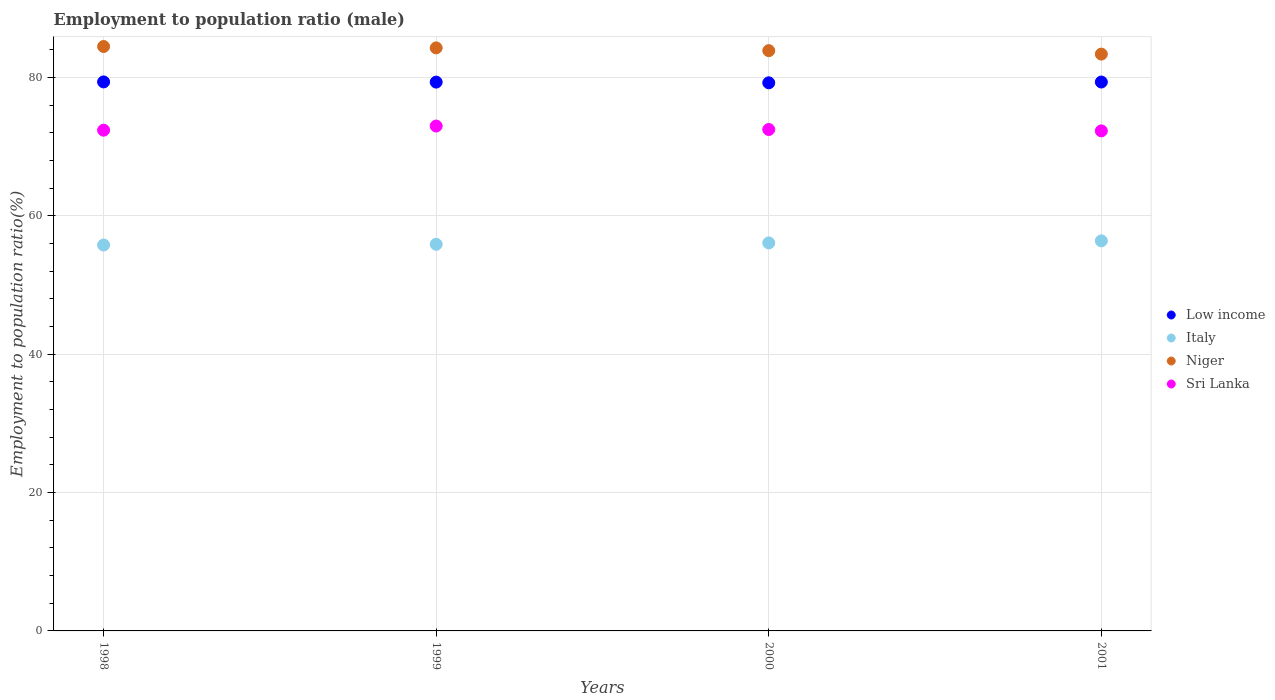How many different coloured dotlines are there?
Give a very brief answer. 4. Is the number of dotlines equal to the number of legend labels?
Make the answer very short. Yes. What is the employment to population ratio in Italy in 2000?
Provide a short and direct response. 56.1. Across all years, what is the maximum employment to population ratio in Low income?
Provide a short and direct response. 79.38. Across all years, what is the minimum employment to population ratio in Niger?
Offer a terse response. 83.4. In which year was the employment to population ratio in Niger minimum?
Offer a terse response. 2001. What is the total employment to population ratio in Sri Lanka in the graph?
Make the answer very short. 290.2. What is the difference between the employment to population ratio in Italy in 2000 and that in 2001?
Your answer should be compact. -0.3. What is the difference between the employment to population ratio in Low income in 1999 and the employment to population ratio in Sri Lanka in 2000?
Your answer should be compact. 6.85. What is the average employment to population ratio in Niger per year?
Give a very brief answer. 84.03. In the year 2000, what is the difference between the employment to population ratio in Italy and employment to population ratio in Niger?
Provide a succinct answer. -27.8. What is the ratio of the employment to population ratio in Niger in 2000 to that in 2001?
Offer a very short reply. 1.01. Is the difference between the employment to population ratio in Italy in 2000 and 2001 greater than the difference between the employment to population ratio in Niger in 2000 and 2001?
Offer a very short reply. No. What is the difference between the highest and the second highest employment to population ratio in Low income?
Keep it short and to the point. 0.02. What is the difference between the highest and the lowest employment to population ratio in Sri Lanka?
Your answer should be very brief. 0.7. In how many years, is the employment to population ratio in Sri Lanka greater than the average employment to population ratio in Sri Lanka taken over all years?
Your answer should be compact. 1. Is the sum of the employment to population ratio in Low income in 1998 and 1999 greater than the maximum employment to population ratio in Sri Lanka across all years?
Your answer should be very brief. Yes. Is it the case that in every year, the sum of the employment to population ratio in Sri Lanka and employment to population ratio in Niger  is greater than the sum of employment to population ratio in Italy and employment to population ratio in Low income?
Give a very brief answer. No. Is the employment to population ratio in Low income strictly greater than the employment to population ratio in Sri Lanka over the years?
Offer a very short reply. Yes. Is the employment to population ratio in Niger strictly less than the employment to population ratio in Sri Lanka over the years?
Offer a terse response. No. How many years are there in the graph?
Offer a very short reply. 4. What is the difference between two consecutive major ticks on the Y-axis?
Give a very brief answer. 20. Are the values on the major ticks of Y-axis written in scientific E-notation?
Provide a short and direct response. No. Does the graph contain grids?
Offer a terse response. Yes. What is the title of the graph?
Your answer should be compact. Employment to population ratio (male). Does "Middle East & North Africa (developing only)" appear as one of the legend labels in the graph?
Give a very brief answer. No. What is the label or title of the X-axis?
Ensure brevity in your answer.  Years. What is the label or title of the Y-axis?
Your answer should be compact. Employment to population ratio(%). What is the Employment to population ratio(%) in Low income in 1998?
Provide a succinct answer. 79.38. What is the Employment to population ratio(%) in Italy in 1998?
Your answer should be compact. 55.8. What is the Employment to population ratio(%) of Niger in 1998?
Ensure brevity in your answer.  84.5. What is the Employment to population ratio(%) in Sri Lanka in 1998?
Provide a succinct answer. 72.4. What is the Employment to population ratio(%) in Low income in 1999?
Provide a short and direct response. 79.35. What is the Employment to population ratio(%) in Italy in 1999?
Your answer should be very brief. 55.9. What is the Employment to population ratio(%) of Niger in 1999?
Your answer should be compact. 84.3. What is the Employment to population ratio(%) of Sri Lanka in 1999?
Offer a very short reply. 73. What is the Employment to population ratio(%) in Low income in 2000?
Make the answer very short. 79.25. What is the Employment to population ratio(%) in Italy in 2000?
Provide a succinct answer. 56.1. What is the Employment to population ratio(%) in Niger in 2000?
Ensure brevity in your answer.  83.9. What is the Employment to population ratio(%) in Sri Lanka in 2000?
Your answer should be compact. 72.5. What is the Employment to population ratio(%) of Low income in 2001?
Keep it short and to the point. 79.36. What is the Employment to population ratio(%) in Italy in 2001?
Offer a terse response. 56.4. What is the Employment to population ratio(%) in Niger in 2001?
Keep it short and to the point. 83.4. What is the Employment to population ratio(%) in Sri Lanka in 2001?
Provide a short and direct response. 72.3. Across all years, what is the maximum Employment to population ratio(%) of Low income?
Provide a short and direct response. 79.38. Across all years, what is the maximum Employment to population ratio(%) of Italy?
Your response must be concise. 56.4. Across all years, what is the maximum Employment to population ratio(%) of Niger?
Keep it short and to the point. 84.5. Across all years, what is the minimum Employment to population ratio(%) in Low income?
Your answer should be compact. 79.25. Across all years, what is the minimum Employment to population ratio(%) in Italy?
Your answer should be compact. 55.8. Across all years, what is the minimum Employment to population ratio(%) of Niger?
Offer a terse response. 83.4. Across all years, what is the minimum Employment to population ratio(%) in Sri Lanka?
Provide a short and direct response. 72.3. What is the total Employment to population ratio(%) in Low income in the graph?
Make the answer very short. 317.34. What is the total Employment to population ratio(%) in Italy in the graph?
Give a very brief answer. 224.2. What is the total Employment to population ratio(%) in Niger in the graph?
Give a very brief answer. 336.1. What is the total Employment to population ratio(%) in Sri Lanka in the graph?
Give a very brief answer. 290.2. What is the difference between the Employment to population ratio(%) of Low income in 1998 and that in 1999?
Offer a very short reply. 0.03. What is the difference between the Employment to population ratio(%) of Sri Lanka in 1998 and that in 1999?
Give a very brief answer. -0.6. What is the difference between the Employment to population ratio(%) of Low income in 1998 and that in 2000?
Your answer should be very brief. 0.13. What is the difference between the Employment to population ratio(%) in Italy in 1998 and that in 2000?
Give a very brief answer. -0.3. What is the difference between the Employment to population ratio(%) of Low income in 1998 and that in 2001?
Provide a succinct answer. 0.02. What is the difference between the Employment to population ratio(%) of Sri Lanka in 1998 and that in 2001?
Ensure brevity in your answer.  0.1. What is the difference between the Employment to population ratio(%) of Low income in 1999 and that in 2000?
Keep it short and to the point. 0.1. What is the difference between the Employment to population ratio(%) of Italy in 1999 and that in 2000?
Keep it short and to the point. -0.2. What is the difference between the Employment to population ratio(%) in Low income in 1999 and that in 2001?
Provide a short and direct response. -0.01. What is the difference between the Employment to population ratio(%) in Italy in 1999 and that in 2001?
Your answer should be very brief. -0.5. What is the difference between the Employment to population ratio(%) of Niger in 1999 and that in 2001?
Keep it short and to the point. 0.9. What is the difference between the Employment to population ratio(%) of Low income in 2000 and that in 2001?
Provide a succinct answer. -0.11. What is the difference between the Employment to population ratio(%) of Niger in 2000 and that in 2001?
Make the answer very short. 0.5. What is the difference between the Employment to population ratio(%) in Sri Lanka in 2000 and that in 2001?
Offer a terse response. 0.2. What is the difference between the Employment to population ratio(%) of Low income in 1998 and the Employment to population ratio(%) of Italy in 1999?
Your answer should be very brief. 23.48. What is the difference between the Employment to population ratio(%) of Low income in 1998 and the Employment to population ratio(%) of Niger in 1999?
Give a very brief answer. -4.92. What is the difference between the Employment to population ratio(%) of Low income in 1998 and the Employment to population ratio(%) of Sri Lanka in 1999?
Keep it short and to the point. 6.38. What is the difference between the Employment to population ratio(%) of Italy in 1998 and the Employment to population ratio(%) of Niger in 1999?
Your answer should be very brief. -28.5. What is the difference between the Employment to population ratio(%) of Italy in 1998 and the Employment to population ratio(%) of Sri Lanka in 1999?
Offer a terse response. -17.2. What is the difference between the Employment to population ratio(%) of Low income in 1998 and the Employment to population ratio(%) of Italy in 2000?
Offer a terse response. 23.28. What is the difference between the Employment to population ratio(%) of Low income in 1998 and the Employment to population ratio(%) of Niger in 2000?
Your response must be concise. -4.52. What is the difference between the Employment to population ratio(%) in Low income in 1998 and the Employment to population ratio(%) in Sri Lanka in 2000?
Keep it short and to the point. 6.88. What is the difference between the Employment to population ratio(%) of Italy in 1998 and the Employment to population ratio(%) of Niger in 2000?
Keep it short and to the point. -28.1. What is the difference between the Employment to population ratio(%) of Italy in 1998 and the Employment to population ratio(%) of Sri Lanka in 2000?
Ensure brevity in your answer.  -16.7. What is the difference between the Employment to population ratio(%) of Niger in 1998 and the Employment to population ratio(%) of Sri Lanka in 2000?
Make the answer very short. 12. What is the difference between the Employment to population ratio(%) in Low income in 1998 and the Employment to population ratio(%) in Italy in 2001?
Offer a terse response. 22.98. What is the difference between the Employment to population ratio(%) of Low income in 1998 and the Employment to population ratio(%) of Niger in 2001?
Offer a terse response. -4.02. What is the difference between the Employment to population ratio(%) of Low income in 1998 and the Employment to population ratio(%) of Sri Lanka in 2001?
Ensure brevity in your answer.  7.08. What is the difference between the Employment to population ratio(%) in Italy in 1998 and the Employment to population ratio(%) in Niger in 2001?
Your response must be concise. -27.6. What is the difference between the Employment to population ratio(%) in Italy in 1998 and the Employment to population ratio(%) in Sri Lanka in 2001?
Provide a short and direct response. -16.5. What is the difference between the Employment to population ratio(%) in Niger in 1998 and the Employment to population ratio(%) in Sri Lanka in 2001?
Provide a succinct answer. 12.2. What is the difference between the Employment to population ratio(%) of Low income in 1999 and the Employment to population ratio(%) of Italy in 2000?
Give a very brief answer. 23.25. What is the difference between the Employment to population ratio(%) of Low income in 1999 and the Employment to population ratio(%) of Niger in 2000?
Offer a very short reply. -4.55. What is the difference between the Employment to population ratio(%) of Low income in 1999 and the Employment to population ratio(%) of Sri Lanka in 2000?
Provide a short and direct response. 6.85. What is the difference between the Employment to population ratio(%) of Italy in 1999 and the Employment to population ratio(%) of Sri Lanka in 2000?
Give a very brief answer. -16.6. What is the difference between the Employment to population ratio(%) in Low income in 1999 and the Employment to population ratio(%) in Italy in 2001?
Your answer should be compact. 22.95. What is the difference between the Employment to population ratio(%) in Low income in 1999 and the Employment to population ratio(%) in Niger in 2001?
Ensure brevity in your answer.  -4.05. What is the difference between the Employment to population ratio(%) in Low income in 1999 and the Employment to population ratio(%) in Sri Lanka in 2001?
Offer a terse response. 7.05. What is the difference between the Employment to population ratio(%) in Italy in 1999 and the Employment to population ratio(%) in Niger in 2001?
Your answer should be compact. -27.5. What is the difference between the Employment to population ratio(%) in Italy in 1999 and the Employment to population ratio(%) in Sri Lanka in 2001?
Your answer should be compact. -16.4. What is the difference between the Employment to population ratio(%) of Low income in 2000 and the Employment to population ratio(%) of Italy in 2001?
Offer a terse response. 22.85. What is the difference between the Employment to population ratio(%) of Low income in 2000 and the Employment to population ratio(%) of Niger in 2001?
Offer a very short reply. -4.15. What is the difference between the Employment to population ratio(%) in Low income in 2000 and the Employment to population ratio(%) in Sri Lanka in 2001?
Your answer should be very brief. 6.95. What is the difference between the Employment to population ratio(%) in Italy in 2000 and the Employment to population ratio(%) in Niger in 2001?
Make the answer very short. -27.3. What is the difference between the Employment to population ratio(%) in Italy in 2000 and the Employment to population ratio(%) in Sri Lanka in 2001?
Ensure brevity in your answer.  -16.2. What is the difference between the Employment to population ratio(%) of Niger in 2000 and the Employment to population ratio(%) of Sri Lanka in 2001?
Make the answer very short. 11.6. What is the average Employment to population ratio(%) of Low income per year?
Offer a very short reply. 79.34. What is the average Employment to population ratio(%) of Italy per year?
Provide a succinct answer. 56.05. What is the average Employment to population ratio(%) of Niger per year?
Provide a succinct answer. 84.03. What is the average Employment to population ratio(%) of Sri Lanka per year?
Offer a very short reply. 72.55. In the year 1998, what is the difference between the Employment to population ratio(%) of Low income and Employment to population ratio(%) of Italy?
Make the answer very short. 23.58. In the year 1998, what is the difference between the Employment to population ratio(%) of Low income and Employment to population ratio(%) of Niger?
Ensure brevity in your answer.  -5.12. In the year 1998, what is the difference between the Employment to population ratio(%) of Low income and Employment to population ratio(%) of Sri Lanka?
Your answer should be very brief. 6.98. In the year 1998, what is the difference between the Employment to population ratio(%) of Italy and Employment to population ratio(%) of Niger?
Ensure brevity in your answer.  -28.7. In the year 1998, what is the difference between the Employment to population ratio(%) of Italy and Employment to population ratio(%) of Sri Lanka?
Provide a succinct answer. -16.6. In the year 1999, what is the difference between the Employment to population ratio(%) in Low income and Employment to population ratio(%) in Italy?
Offer a terse response. 23.45. In the year 1999, what is the difference between the Employment to population ratio(%) of Low income and Employment to population ratio(%) of Niger?
Your answer should be very brief. -4.95. In the year 1999, what is the difference between the Employment to population ratio(%) in Low income and Employment to population ratio(%) in Sri Lanka?
Keep it short and to the point. 6.35. In the year 1999, what is the difference between the Employment to population ratio(%) of Italy and Employment to population ratio(%) of Niger?
Offer a terse response. -28.4. In the year 1999, what is the difference between the Employment to population ratio(%) of Italy and Employment to population ratio(%) of Sri Lanka?
Offer a very short reply. -17.1. In the year 1999, what is the difference between the Employment to population ratio(%) in Niger and Employment to population ratio(%) in Sri Lanka?
Offer a terse response. 11.3. In the year 2000, what is the difference between the Employment to population ratio(%) of Low income and Employment to population ratio(%) of Italy?
Your answer should be compact. 23.15. In the year 2000, what is the difference between the Employment to population ratio(%) in Low income and Employment to population ratio(%) in Niger?
Your answer should be very brief. -4.65. In the year 2000, what is the difference between the Employment to population ratio(%) of Low income and Employment to population ratio(%) of Sri Lanka?
Offer a terse response. 6.75. In the year 2000, what is the difference between the Employment to population ratio(%) of Italy and Employment to population ratio(%) of Niger?
Ensure brevity in your answer.  -27.8. In the year 2000, what is the difference between the Employment to population ratio(%) of Italy and Employment to population ratio(%) of Sri Lanka?
Offer a very short reply. -16.4. In the year 2000, what is the difference between the Employment to population ratio(%) of Niger and Employment to population ratio(%) of Sri Lanka?
Offer a terse response. 11.4. In the year 2001, what is the difference between the Employment to population ratio(%) of Low income and Employment to population ratio(%) of Italy?
Make the answer very short. 22.96. In the year 2001, what is the difference between the Employment to population ratio(%) of Low income and Employment to population ratio(%) of Niger?
Ensure brevity in your answer.  -4.04. In the year 2001, what is the difference between the Employment to population ratio(%) of Low income and Employment to population ratio(%) of Sri Lanka?
Keep it short and to the point. 7.06. In the year 2001, what is the difference between the Employment to population ratio(%) in Italy and Employment to population ratio(%) in Sri Lanka?
Provide a short and direct response. -15.9. What is the ratio of the Employment to population ratio(%) of Italy in 1998 to that in 1999?
Provide a short and direct response. 1. What is the ratio of the Employment to population ratio(%) in Italy in 1998 to that in 2000?
Ensure brevity in your answer.  0.99. What is the ratio of the Employment to population ratio(%) in Italy in 1998 to that in 2001?
Ensure brevity in your answer.  0.99. What is the ratio of the Employment to population ratio(%) in Niger in 1998 to that in 2001?
Ensure brevity in your answer.  1.01. What is the ratio of the Employment to population ratio(%) of Italy in 1999 to that in 2000?
Offer a very short reply. 1. What is the ratio of the Employment to population ratio(%) of Low income in 1999 to that in 2001?
Your answer should be very brief. 1. What is the ratio of the Employment to population ratio(%) of Niger in 1999 to that in 2001?
Offer a very short reply. 1.01. What is the ratio of the Employment to population ratio(%) in Sri Lanka in 1999 to that in 2001?
Your answer should be compact. 1.01. What is the ratio of the Employment to population ratio(%) of Low income in 2000 to that in 2001?
Your answer should be very brief. 1. What is the ratio of the Employment to population ratio(%) in Sri Lanka in 2000 to that in 2001?
Keep it short and to the point. 1. What is the difference between the highest and the second highest Employment to population ratio(%) in Low income?
Offer a terse response. 0.02. What is the difference between the highest and the second highest Employment to population ratio(%) in Italy?
Provide a short and direct response. 0.3. What is the difference between the highest and the lowest Employment to population ratio(%) of Low income?
Offer a very short reply. 0.13. What is the difference between the highest and the lowest Employment to population ratio(%) in Italy?
Keep it short and to the point. 0.6. 